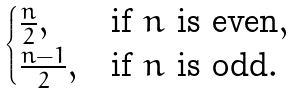<formula> <loc_0><loc_0><loc_500><loc_500>\begin{cases} \frac { n } { 2 } , & \text {if $n$ is even} , \\ \frac { n - 1 } { 2 } , & \text {if $n$ is odd} . \end{cases}</formula> 